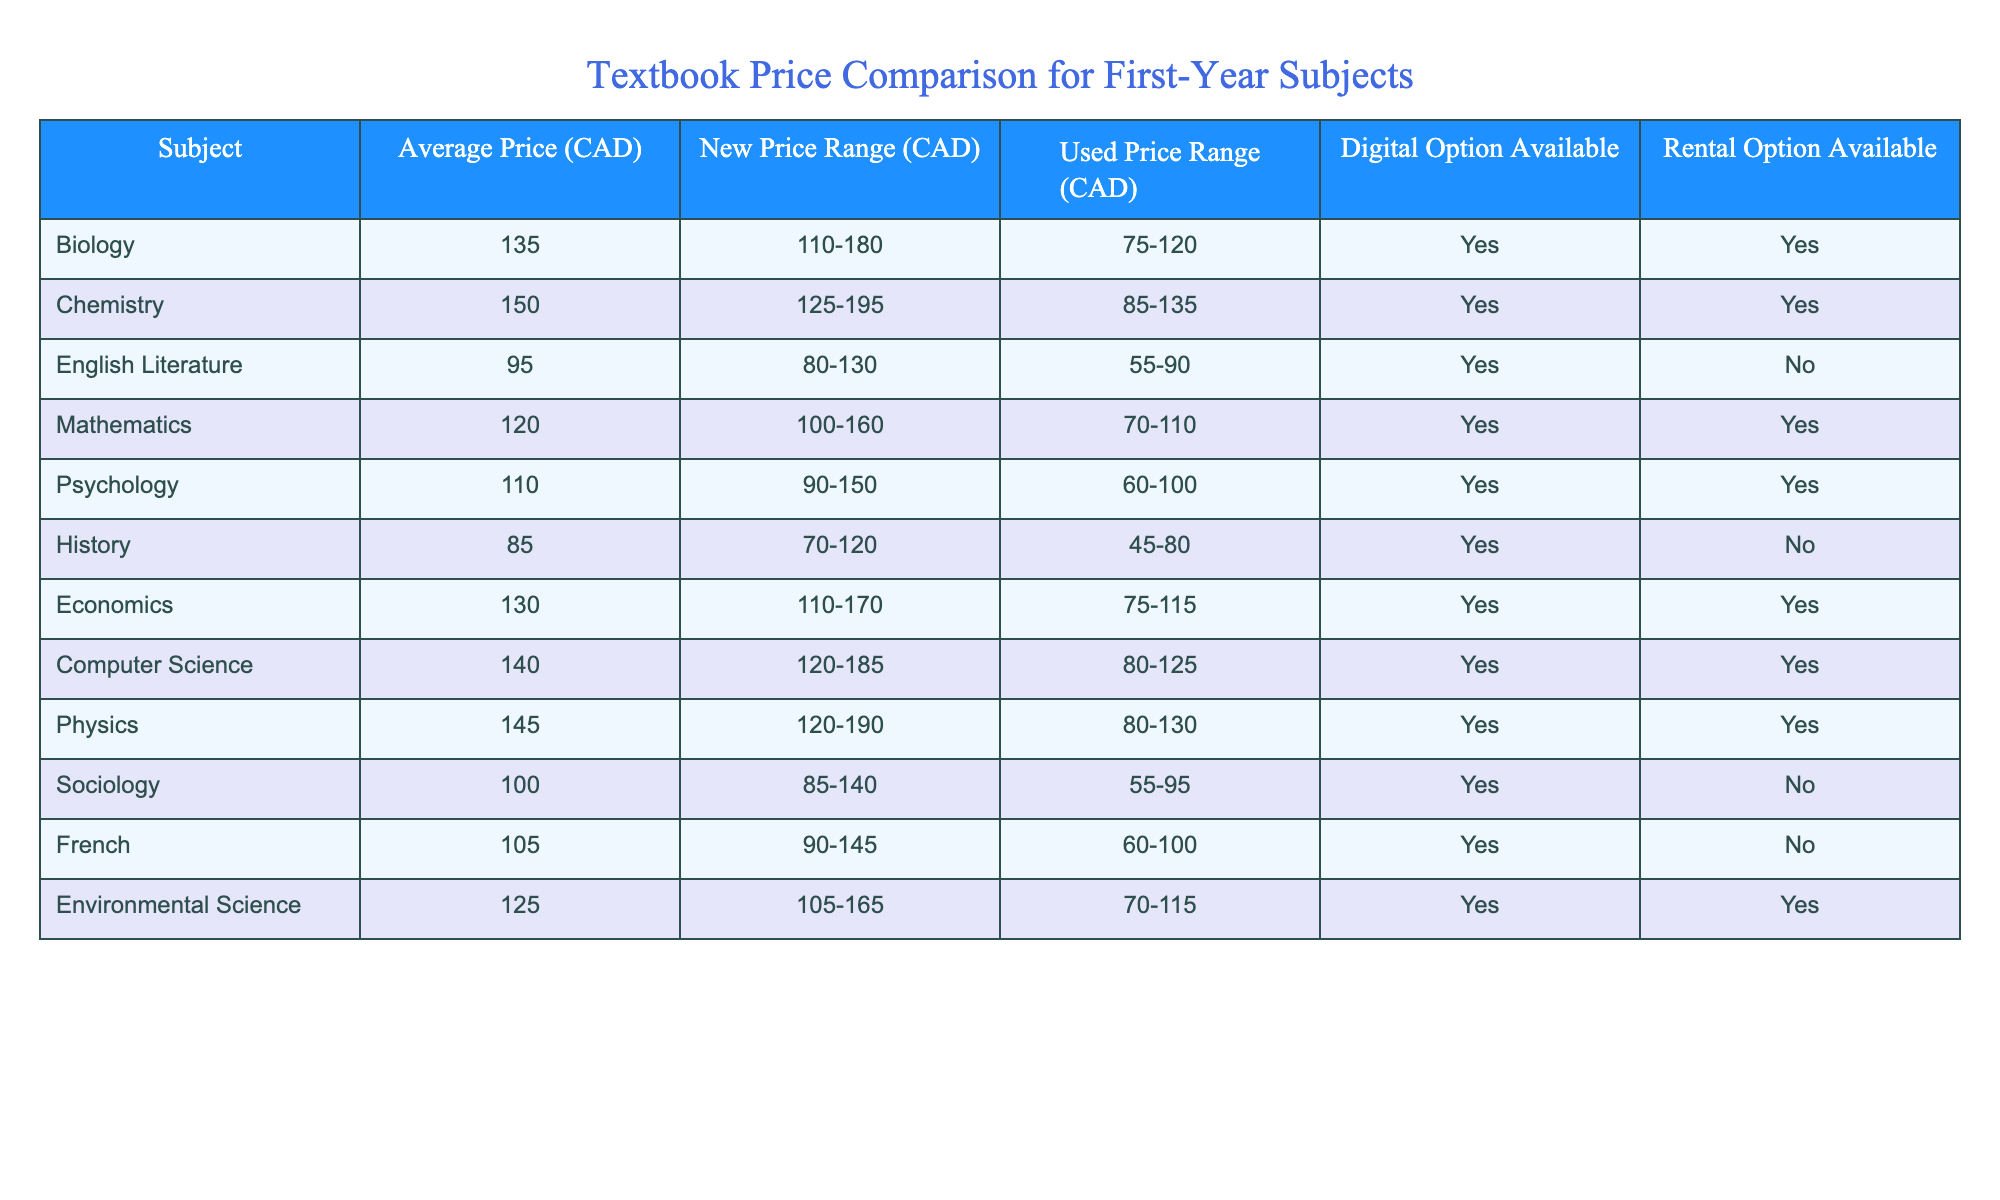What subject has the highest average textbook price? Looking at the 'Average Price (CAD)' column, the highest value is 150 for Chemistry.
Answer: Chemistry Which subject has the lowest used textbook price range? Referring to the 'Used Price Range (CAD)' column, the lowest range is 45-80 for History.
Answer: History What is the average price of textbooks for Psychology and Sociology combined? The average prices are 110 for Psychology and 100 for Sociology. Summing them gives 110 + 100 = 210, and dividing by 2 gives 210/2 = 105.
Answer: 105 Is there a digital option available for English Literature? Looking at the 'Digital Option Available' column, it indicates 'No' for English Literature.
Answer: No Which subjects have a rental option available? Checking the 'Rental Option Available' column, the subjects with 'Yes' are Biology, Chemistry, Mathematics, Psychology, Economics, Computer Science, Physics, and Environmental Science.
Answer: Eight subjects What is the difference between the average prices of Biology and History? The average price for Biology is 135 and for History is 85. The difference is 135 - 85 = 50.
Answer: 50 Which subject has the largest range in new textbook prices? The 'New Price Range (CAD)' column for Chemistry (125-195) gives a range of 195 - 125 = 70, and comparing it with others, it is the highest.
Answer: Chemistry What percentage of subjects have a digital option available? There are 12 subjects listed, and 9 of them have a digital option ('Yes'). The percentage is (9/12) * 100 = 75%.
Answer: 75% 